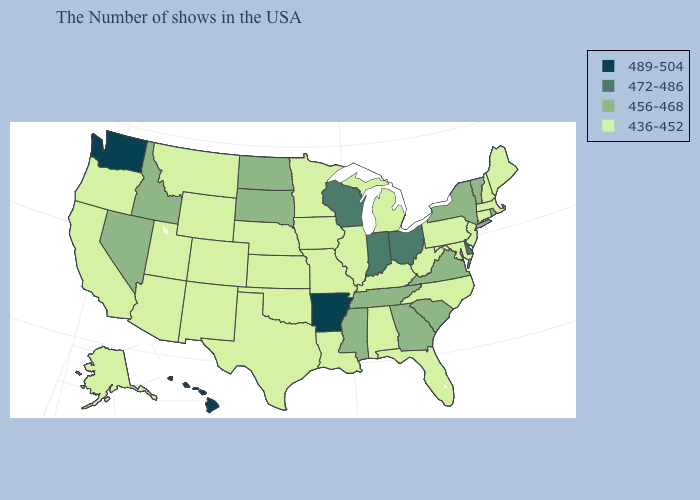Among the states that border New York , which have the highest value?
Give a very brief answer. Vermont. Among the states that border Nebraska , does South Dakota have the highest value?
Quick response, please. Yes. What is the highest value in the USA?
Be succinct. 489-504. What is the lowest value in the Northeast?
Be succinct. 436-452. What is the value of North Carolina?
Be succinct. 436-452. Is the legend a continuous bar?
Quick response, please. No. Does Oklahoma have the same value as Arkansas?
Short answer required. No. Does Oregon have the highest value in the USA?
Concise answer only. No. What is the value of New Jersey?
Keep it brief. 436-452. Name the states that have a value in the range 456-468?
Concise answer only. Rhode Island, Vermont, New York, Virginia, South Carolina, Georgia, Tennessee, Mississippi, South Dakota, North Dakota, Idaho, Nevada. Is the legend a continuous bar?
Short answer required. No. Name the states that have a value in the range 436-452?
Quick response, please. Maine, Massachusetts, New Hampshire, Connecticut, New Jersey, Maryland, Pennsylvania, North Carolina, West Virginia, Florida, Michigan, Kentucky, Alabama, Illinois, Louisiana, Missouri, Minnesota, Iowa, Kansas, Nebraska, Oklahoma, Texas, Wyoming, Colorado, New Mexico, Utah, Montana, Arizona, California, Oregon, Alaska. Name the states that have a value in the range 436-452?
Write a very short answer. Maine, Massachusetts, New Hampshire, Connecticut, New Jersey, Maryland, Pennsylvania, North Carolina, West Virginia, Florida, Michigan, Kentucky, Alabama, Illinois, Louisiana, Missouri, Minnesota, Iowa, Kansas, Nebraska, Oklahoma, Texas, Wyoming, Colorado, New Mexico, Utah, Montana, Arizona, California, Oregon, Alaska. What is the value of Missouri?
Write a very short answer. 436-452. Name the states that have a value in the range 456-468?
Write a very short answer. Rhode Island, Vermont, New York, Virginia, South Carolina, Georgia, Tennessee, Mississippi, South Dakota, North Dakota, Idaho, Nevada. 